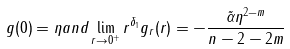<formula> <loc_0><loc_0><loc_500><loc_500>g ( 0 ) = \eta a n d \lim _ { r \to 0 ^ { + } } r ^ { \delta _ { 1 } } g _ { r } ( r ) = - \frac { \tilde { \alpha } \eta ^ { 2 - m } } { n - 2 - 2 m }</formula> 